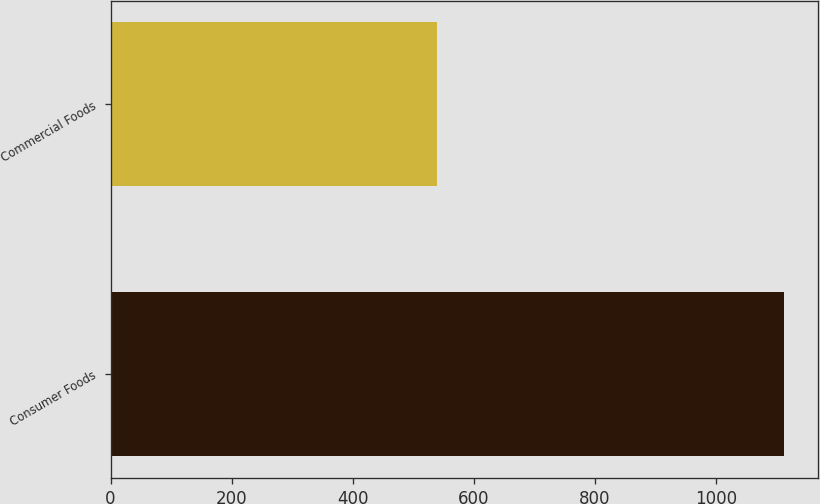Convert chart to OTSL. <chart><loc_0><loc_0><loc_500><loc_500><bar_chart><fcel>Consumer Foods<fcel>Commercial Foods<nl><fcel>1113<fcel>539<nl></chart> 